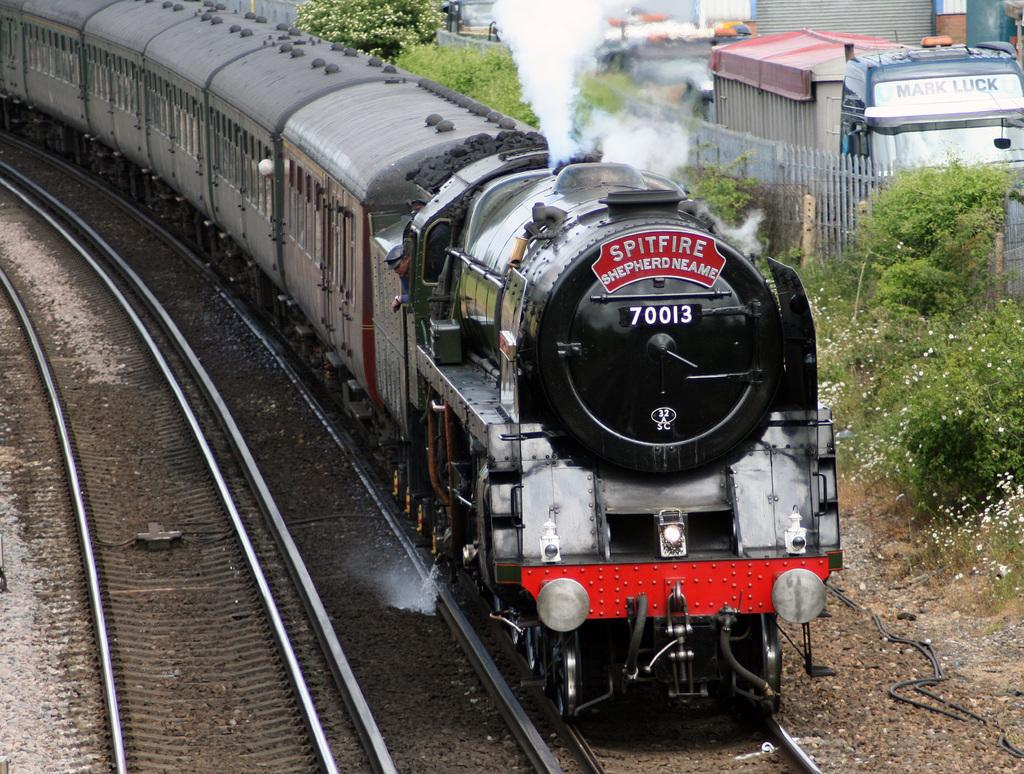Provide a one-sentence caption for the provided image. A Spitfire train moving down the train tracks. 